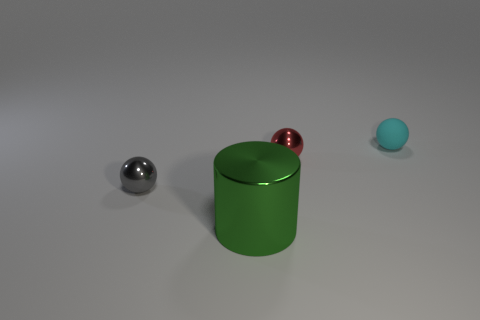There is a cylinder; is its color the same as the metal ball to the right of the large green cylinder?
Keep it short and to the point. No. Is the number of cyan rubber objects that are in front of the large green object the same as the number of objects?
Offer a very short reply. No. How many green things are the same size as the gray metal ball?
Offer a terse response. 0. Is there a large green cylinder?
Offer a very short reply. Yes. There is a tiny object that is in front of the tiny red object; is its shape the same as the shiny object behind the gray ball?
Make the answer very short. Yes. How many tiny objects are red metal things or metallic balls?
Your answer should be very brief. 2. What shape is the red thing that is the same material as the large green cylinder?
Provide a short and direct response. Sphere. Do the gray metal object and the matte thing have the same shape?
Your answer should be very brief. Yes. The big thing has what color?
Offer a very short reply. Green. How many objects are either large green cylinders or small red metallic spheres?
Give a very brief answer. 2. 